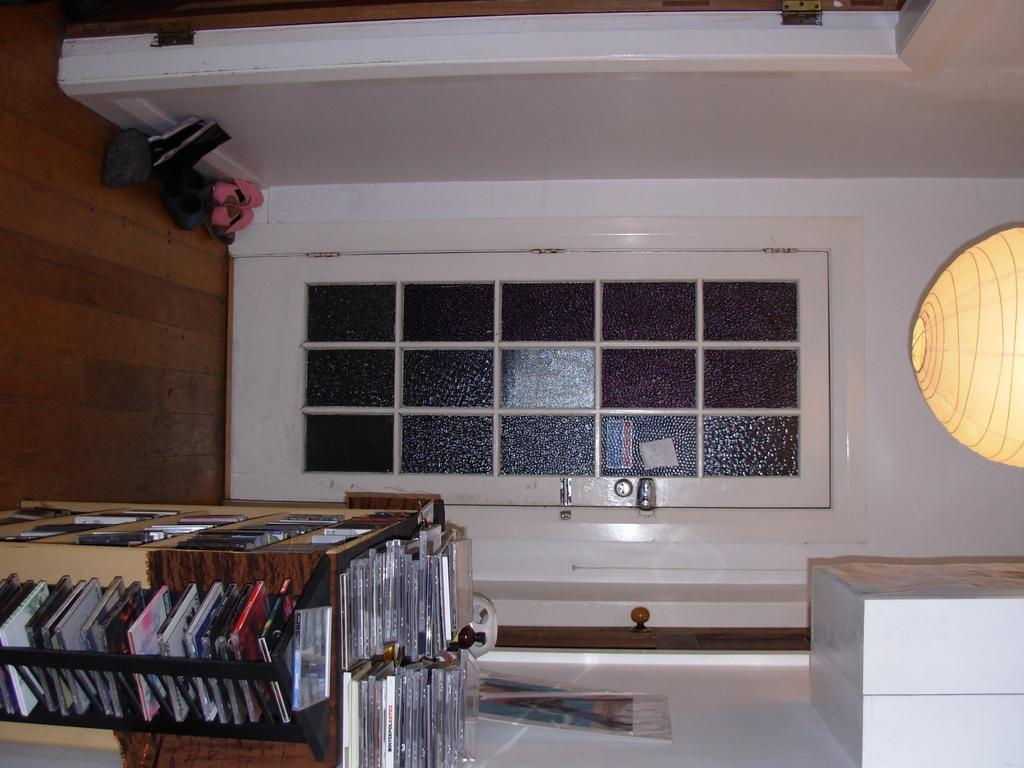What objects are arranged in the image? There are discs arranged in the image. Where are the discs located? The discs are in cupboards, on a door, and on walls. How are the discs organized in the image? The discs are arranged in a specific pattern or order. What type of attention-grabbing prose is written on the discs in the image? There is no prose or writing present on the discs in the image. 